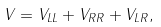<formula> <loc_0><loc_0><loc_500><loc_500>V = V _ { L L } + V _ { R R } + V _ { L R } ,</formula> 